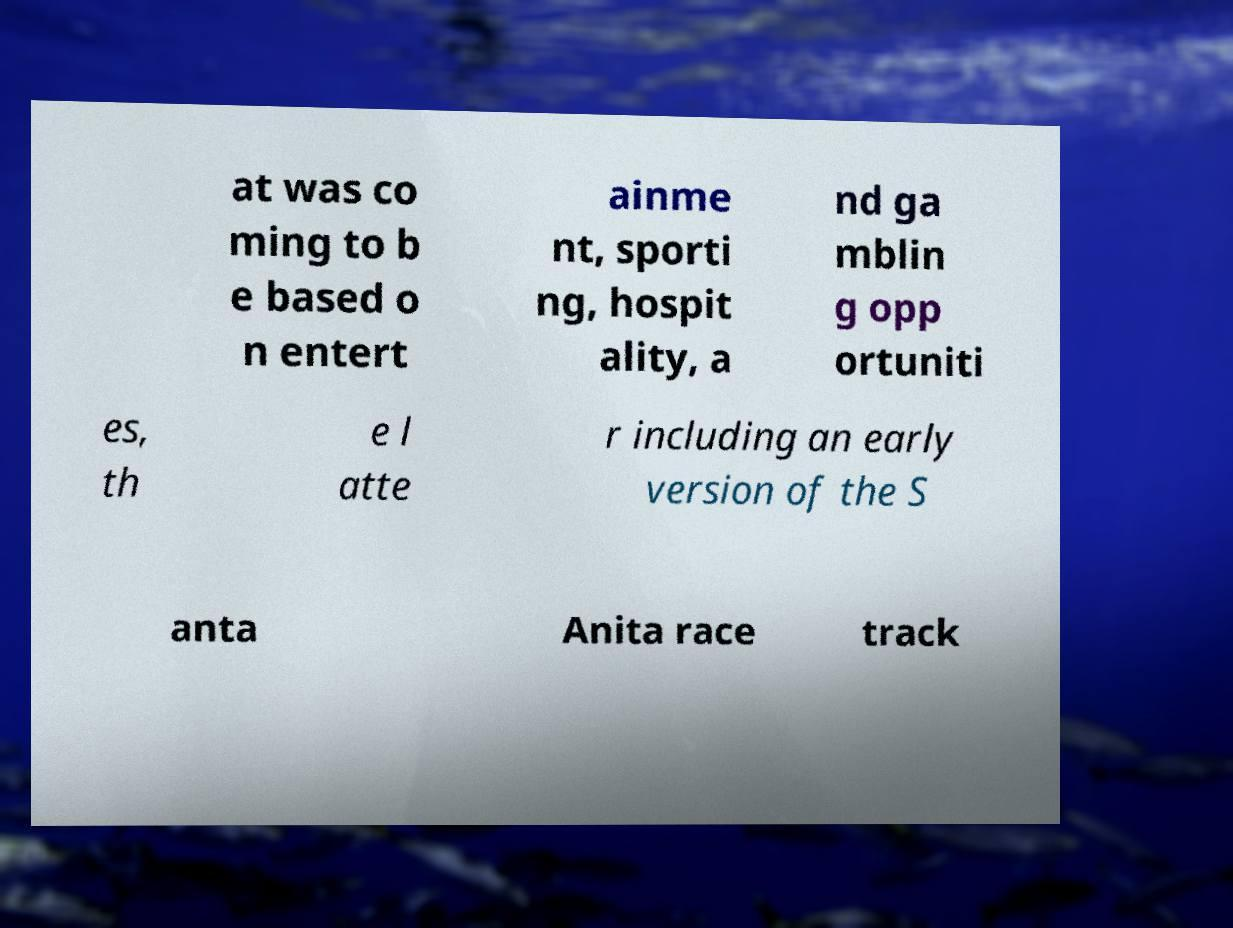What messages or text are displayed in this image? I need them in a readable, typed format. at was co ming to b e based o n entert ainme nt, sporti ng, hospit ality, a nd ga mblin g opp ortuniti es, th e l atte r including an early version of the S anta Anita race track 